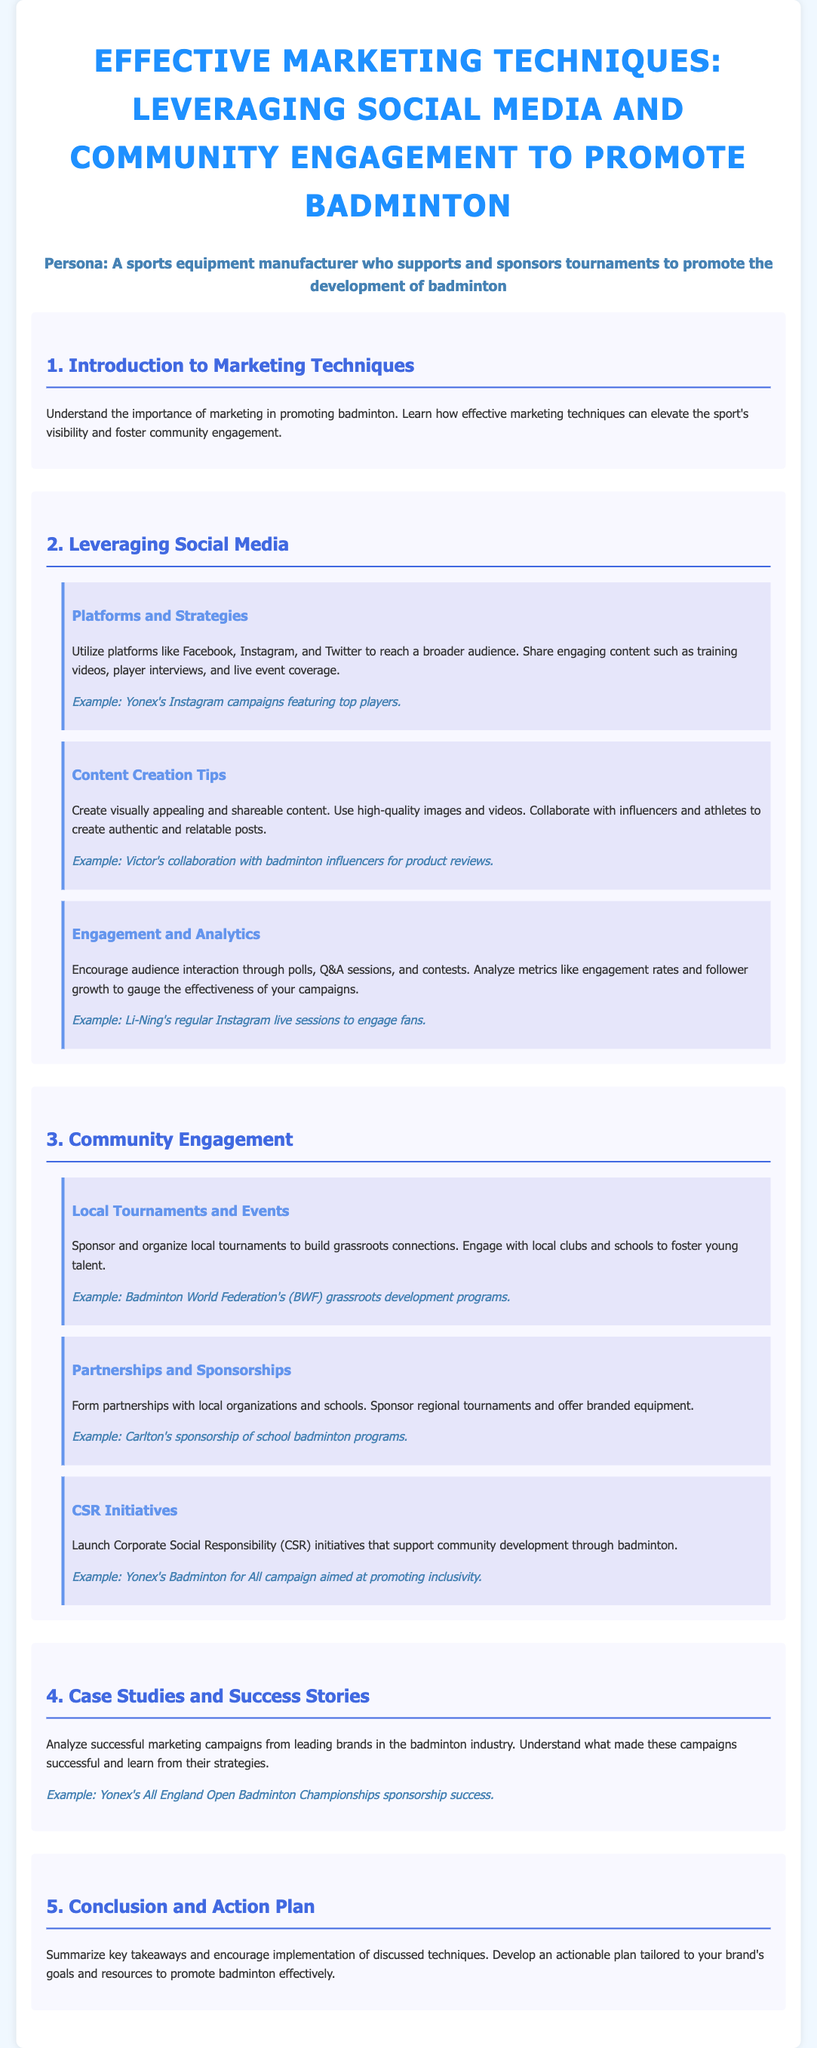What is the title of the lesson plan? The title is explicitly mentioned at the top of the document.
Answer: Effective Marketing Techniques: Leveraging Social Media and Community Engagement to Promote Badminton What platforms are suggested for leveraging social media? The document lists platforms in the social media section.
Answer: Facebook, Instagram, and Twitter What type of content should be created for social media engagement? The document specifies content types under the content creation tips.
Answer: Visually appealing and shareable content What is an example of local community engagement mentioned? The document provides examples of community engagement strategies.
Answer: Badminton World Federation's grassroots development programs What are CSR initiatives aimed at according to the document? The document describes the purpose of CSR initiatives in the community engagement section.
Answer: Supporting community development through badminton What is the focus of partnerships and sponsorships in community engagement? The document outlines the goals of partnerships and sponsorships strategies.
Answer: Form partnerships with local organizations and schools What is the action plan encouraged at the end of the lesson plan? The conclusion section mentions the development of an actionable plan.
Answer: Develop an actionable plan tailored to your brand's goals and resources Which brand is mentioned for its successful marketing campaign in case studies? The case studies section lists brands with successful strategies.
Answer: Yonex 